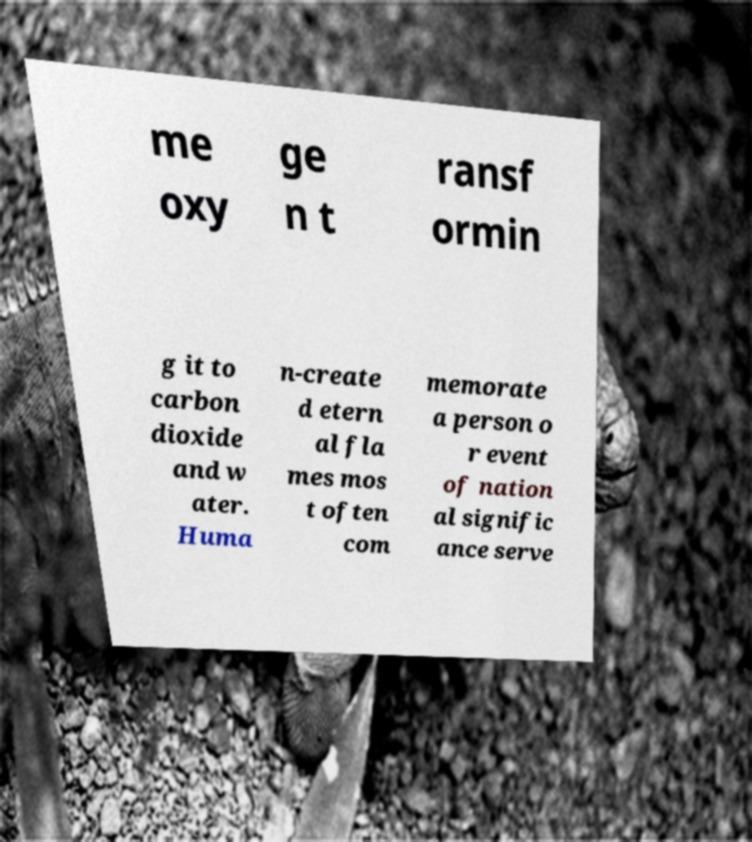Could you extract and type out the text from this image? me oxy ge n t ransf ormin g it to carbon dioxide and w ater. Huma n-create d etern al fla mes mos t often com memorate a person o r event of nation al signific ance serve 